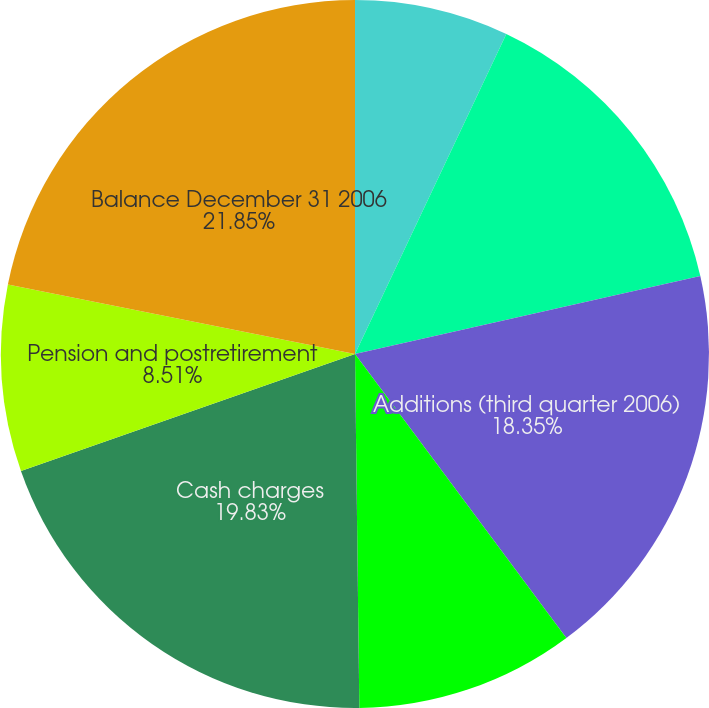Convert chart. <chart><loc_0><loc_0><loc_500><loc_500><pie_chart><fcel>Opening Balance (first quarter<fcel>Additions (second quarter<fcel>Additions (third quarter 2006)<fcel>Additions (fourth quarter<fcel>Cash charges<fcel>Pension and postretirement<fcel>Balance December 31 2006<nl><fcel>7.03%<fcel>14.44%<fcel>18.35%<fcel>9.99%<fcel>19.83%<fcel>8.51%<fcel>21.86%<nl></chart> 